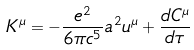<formula> <loc_0><loc_0><loc_500><loc_500>K ^ { \mu } = - \frac { e ^ { 2 } } { 6 \pi c ^ { 5 } } a ^ { 2 } u ^ { \mu } + \frac { d C ^ { \mu } } { d \tau }</formula> 